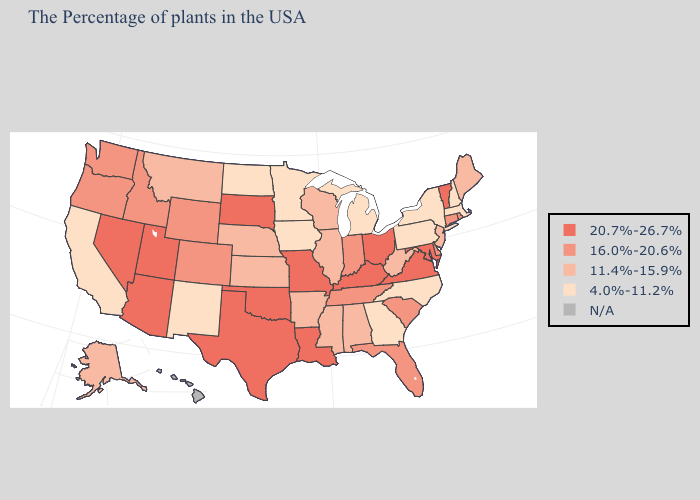What is the lowest value in states that border West Virginia?
Answer briefly. 4.0%-11.2%. Name the states that have a value in the range 20.7%-26.7%?
Be succinct. Vermont, Maryland, Virginia, Ohio, Kentucky, Louisiana, Missouri, Oklahoma, Texas, South Dakota, Utah, Arizona, Nevada. What is the highest value in the West ?
Concise answer only. 20.7%-26.7%. Name the states that have a value in the range 20.7%-26.7%?
Write a very short answer. Vermont, Maryland, Virginia, Ohio, Kentucky, Louisiana, Missouri, Oklahoma, Texas, South Dakota, Utah, Arizona, Nevada. Among the states that border Texas , does Arkansas have the lowest value?
Keep it brief. No. How many symbols are there in the legend?
Quick response, please. 5. Name the states that have a value in the range 4.0%-11.2%?
Answer briefly. Massachusetts, New Hampshire, New York, Pennsylvania, North Carolina, Georgia, Michigan, Minnesota, Iowa, North Dakota, New Mexico, California. Does the first symbol in the legend represent the smallest category?
Answer briefly. No. Among the states that border Illinois , which have the lowest value?
Concise answer only. Iowa. Is the legend a continuous bar?
Give a very brief answer. No. Name the states that have a value in the range 4.0%-11.2%?
Keep it brief. Massachusetts, New Hampshire, New York, Pennsylvania, North Carolina, Georgia, Michigan, Minnesota, Iowa, North Dakota, New Mexico, California. Which states hav the highest value in the West?
Concise answer only. Utah, Arizona, Nevada. What is the lowest value in the USA?
Quick response, please. 4.0%-11.2%. Name the states that have a value in the range 11.4%-15.9%?
Give a very brief answer. Maine, New Jersey, West Virginia, Alabama, Wisconsin, Illinois, Mississippi, Arkansas, Kansas, Nebraska, Montana, Alaska. 